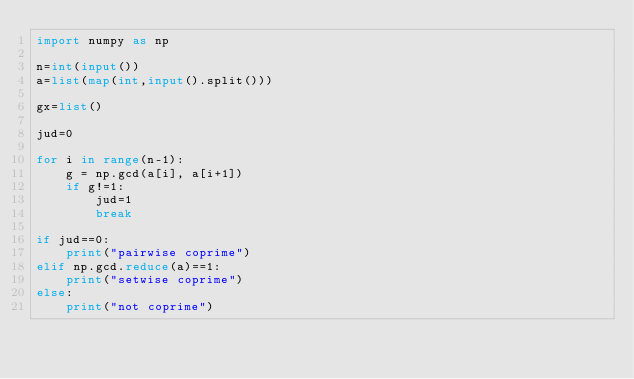Convert code to text. <code><loc_0><loc_0><loc_500><loc_500><_Python_>import numpy as np

n=int(input())
a=list(map(int,input().split()))

gx=list()

jud=0

for i in range(n-1):
    g = np.gcd(a[i], a[i+1])
    if g!=1:
        jud=1
        break

if jud==0:
    print("pairwise coprime")
elif np.gcd.reduce(a)==1:
    print("setwise coprime")
else:
    print("not coprime")
</code> 